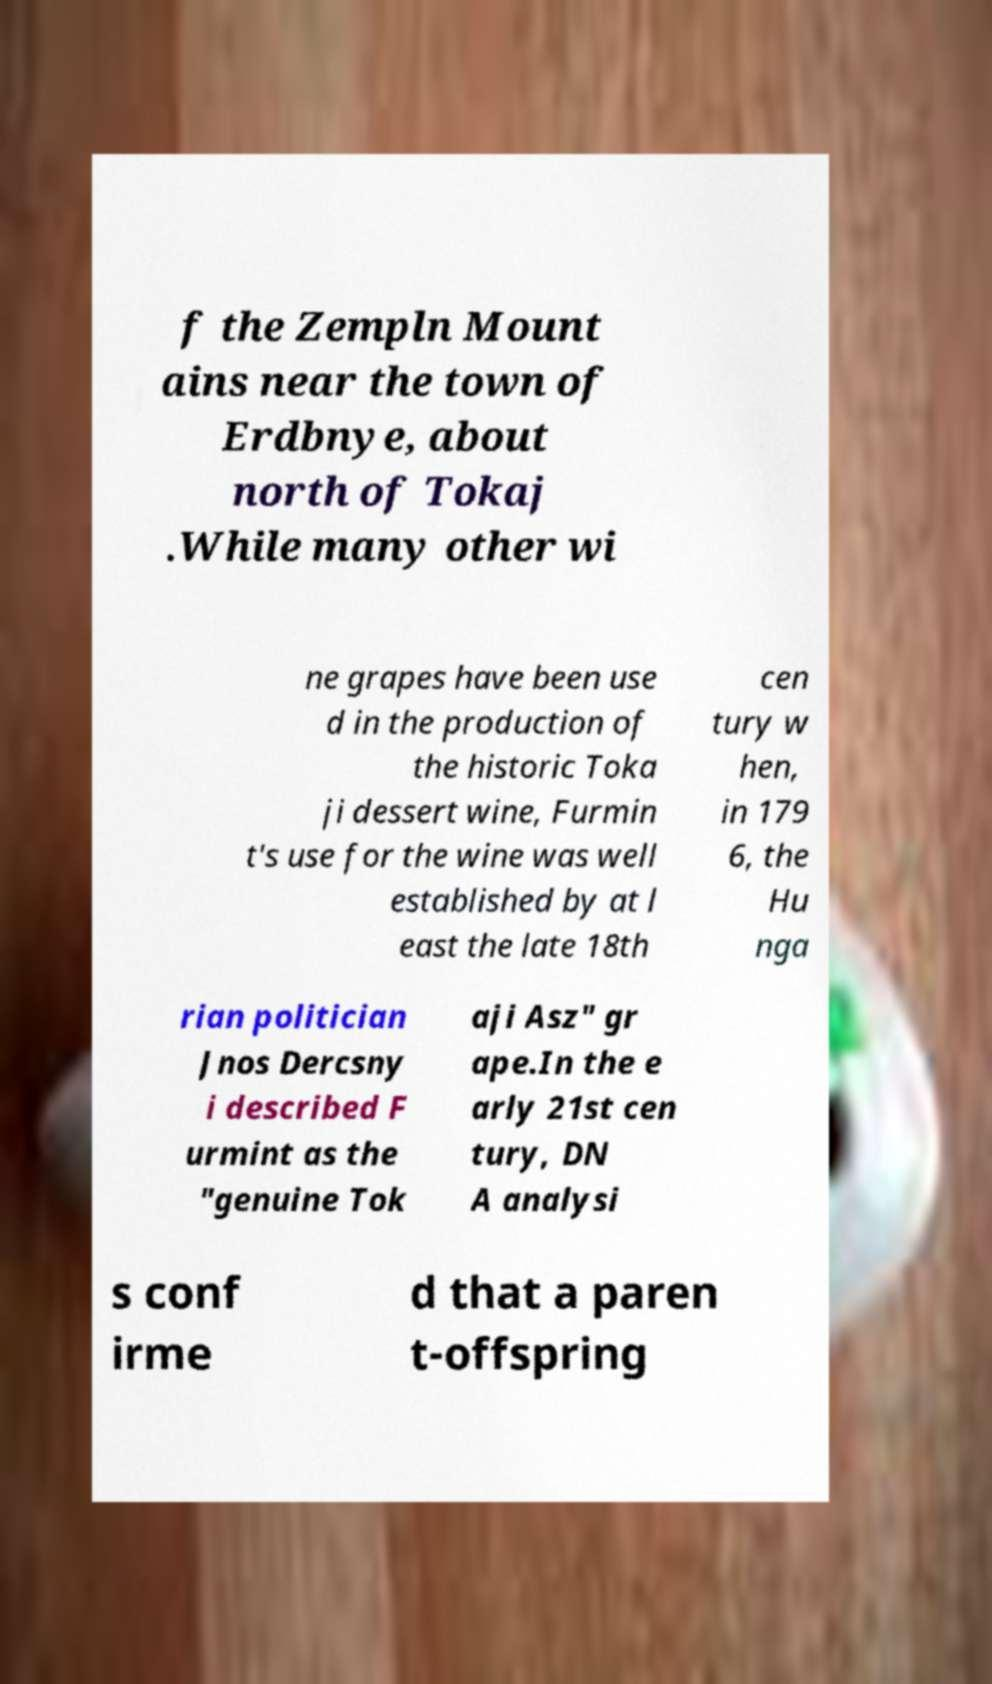Could you assist in decoding the text presented in this image and type it out clearly? f the Zempln Mount ains near the town of Erdbnye, about north of Tokaj .While many other wi ne grapes have been use d in the production of the historic Toka ji dessert wine, Furmin t's use for the wine was well established by at l east the late 18th cen tury w hen, in 179 6, the Hu nga rian politician Jnos Dercsny i described F urmint as the "genuine Tok aji Asz" gr ape.In the e arly 21st cen tury, DN A analysi s conf irme d that a paren t-offspring 